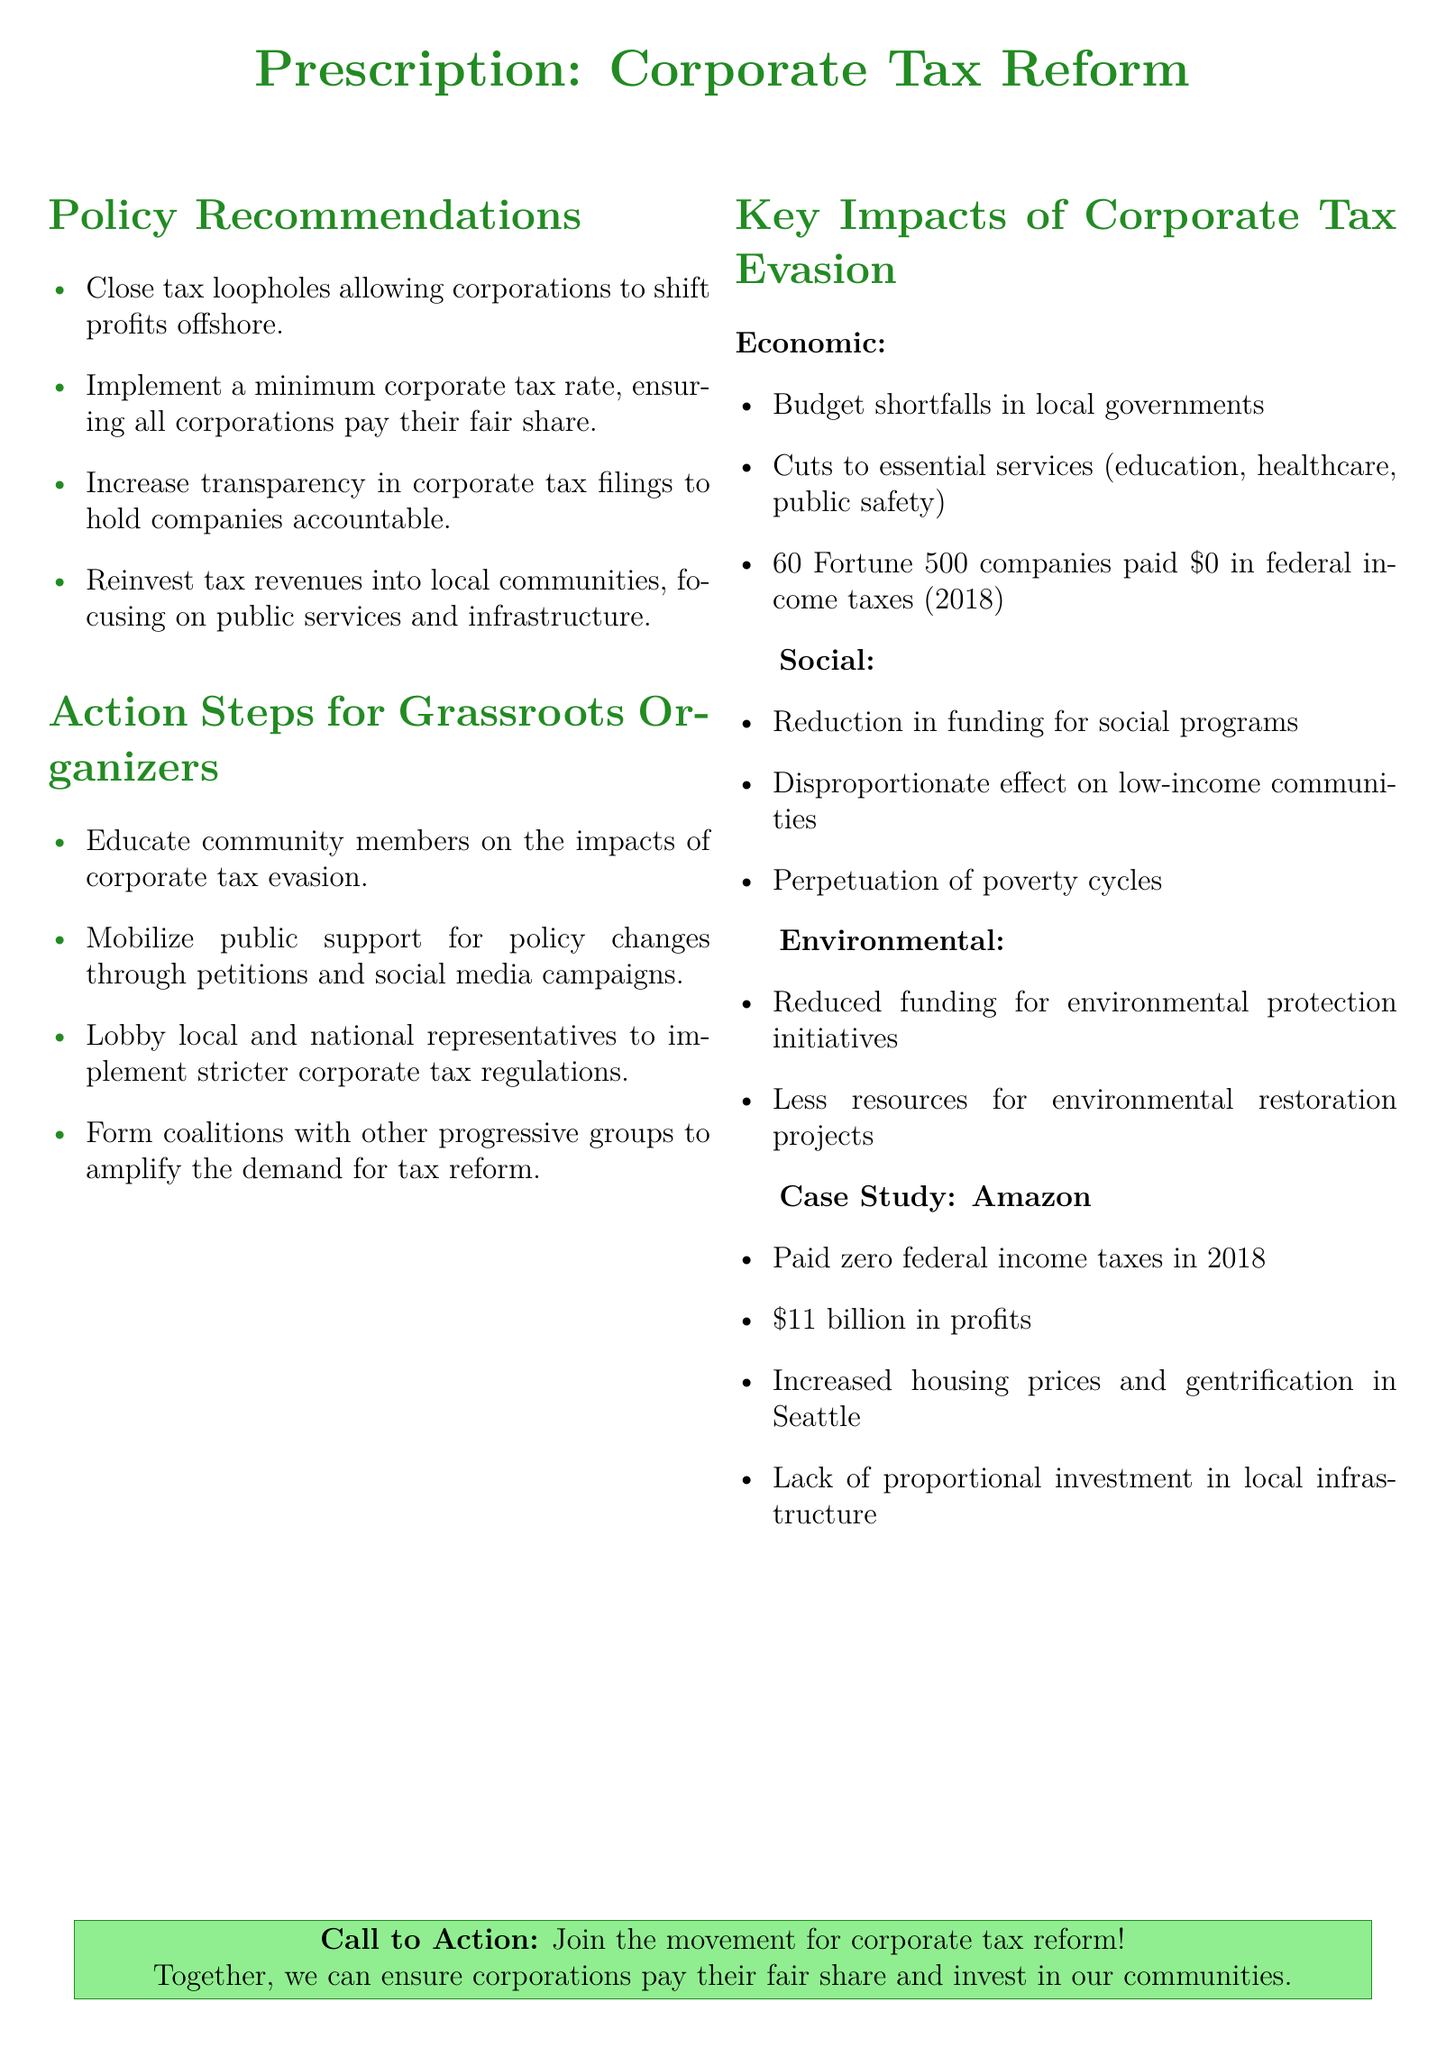What is the title of the document? The title of the document is prominently displayed at the top, indicating the focus on corporate tax reform.
Answer: Corporate Tax Reform How many Fortune 500 companies paid zero in federal income taxes in 2018? The document states that 60 Fortune 500 companies had no federal income tax payments in the specified year.
Answer: 60 What is one recommended action for grassroots organizers? The document lists several actions for grassroots organizers, one of which is to educate community members on the impacts of corporate tax evasion.
Answer: Educate community members Which corporation is highlighted in the case study? The case study focuses specifically on the financial practices and impacts of a well-known corporation.
Answer: Amazon What is one key impact of corporate tax evasion mentioned in the document? The document highlights multiple economic, social, and environmental impacts, one being budget shortfalls in local governments.
Answer: Budget shortfalls in local governments What is the prescribed minimum corporate tax rate? The document advocates for a minimum level of taxation, but it does not specify an exact percentage.
Answer: Not specified How much profit did Amazon report in 2018? The document explicitly mentions the amount of profit reported by Amazon during that year.
Answer: 11 billion What does the call to action encourage? The call to action urges collective efforts towards a significant policy change regarding corporate taxes.
Answer: Join the movement for corporate tax reform 